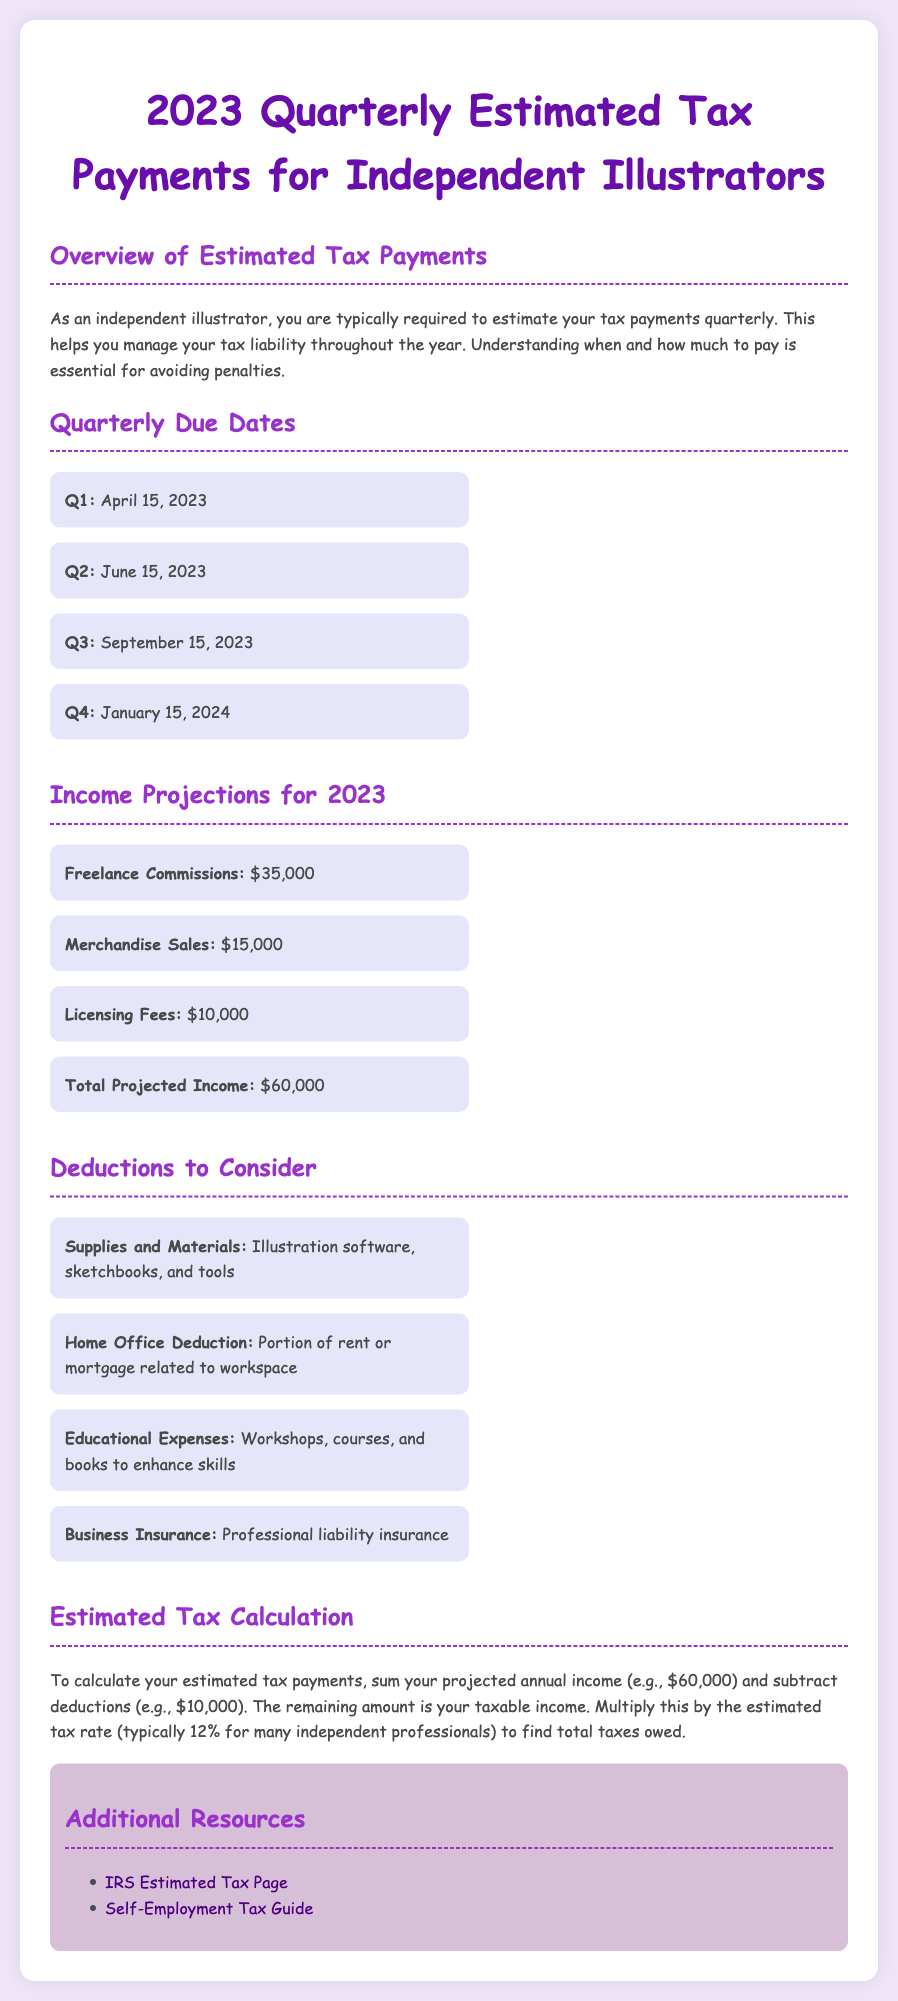what is the total projected income? The total projected income is listed in the income projections section by summing up all income sources.
Answer: $60,000 when is the Q2 tax payment due? The Q2 tax payment due date is specified in the quarterly due dates section of the document.
Answer: June 15, 2023 what deduction is related to workspace expenses? The deduction for workspace expenses is titled "Home Office Deduction" in the deductions section.
Answer: Home Office Deduction how much is projected from freelance commissions? The income projected from freelance commissions is given in the income projections.
Answer: $35,000 what percentage is the estimated tax rate for independent professionals? The estimated tax rate mentioned in the document is typically applicable to independent professionals.
Answer: 12% which resource provides guidance on self-employment tax? The document includes links to resources for further information, including self-employment tax guidance.
Answer: Self-Employment Tax Guide what items are included in supplies and materials deductions? The deductions item specifies examples of what counts as supplies and materials for tax purposes.
Answer: Illustration software, sketchbooks, and tools when is the Q4 tax payment due? The due date for the Q4 tax payment is outlined in the quarterly due dates section of the document.
Answer: January 15, 2024 what are educational expenses listed as deductible? The document provides examples related to educational expenses that can be deducted for tax purposes.
Answer: Workshops, courses, and books to enhance skills 